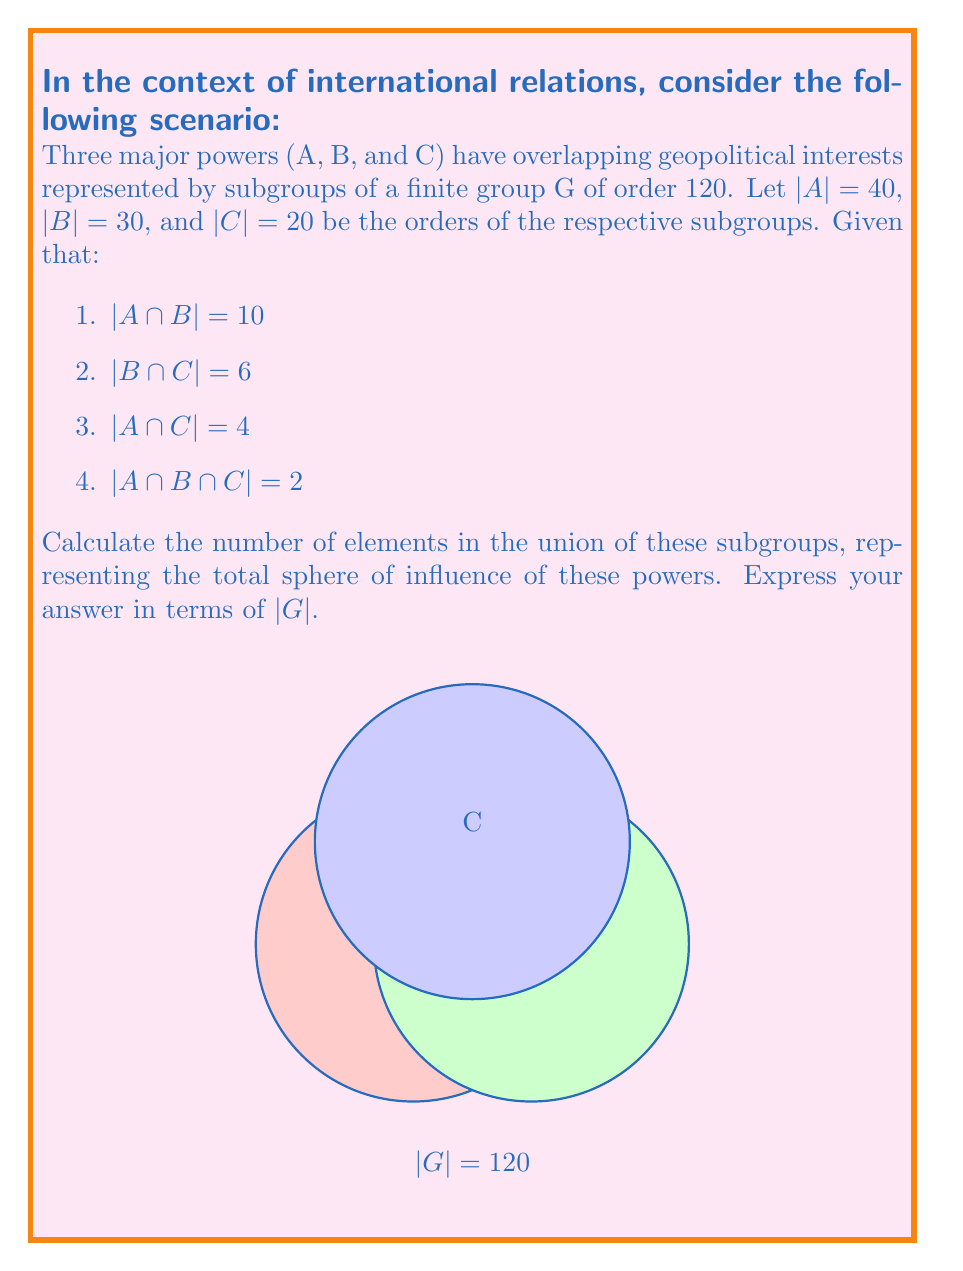Give your solution to this math problem. To solve this problem, we'll use the Inclusion-Exclusion Principle for three sets:

$$|A ∪ B ∪ C| = |A| + |B| + |C| - |A ∩ B| - |B ∩ C| - |A ∩ C| + |A ∩ B ∩ C|$$

Let's substitute the given values:

1. |A| = 40
2. |B| = 30
3. |C| = 20
4. |A ∩ B| = 10
5. |B ∩ C| = 6
6. |A ∩ C| = 4
7. |A ∩ B ∩ C| = 2

Now, let's calculate:

$$|A ∪ B ∪ C| = 40 + 30 + 20 - 10 - 6 - 4 + 2$$

$$|A ∪ B ∪ C| = 90 - 20 + 2 = 72$$

Therefore, the union of these subgroups contains 72 elements.

To express this in terms of |G|:

$$|A ∪ B ∪ C| = 72 = \frac{3}{5}|G|$$

This result indicates that the combined sphere of influence of these three powers covers 3/5 of the total geopolitical landscape represented by group G.
Answer: $\frac{3}{5}|G|$ 